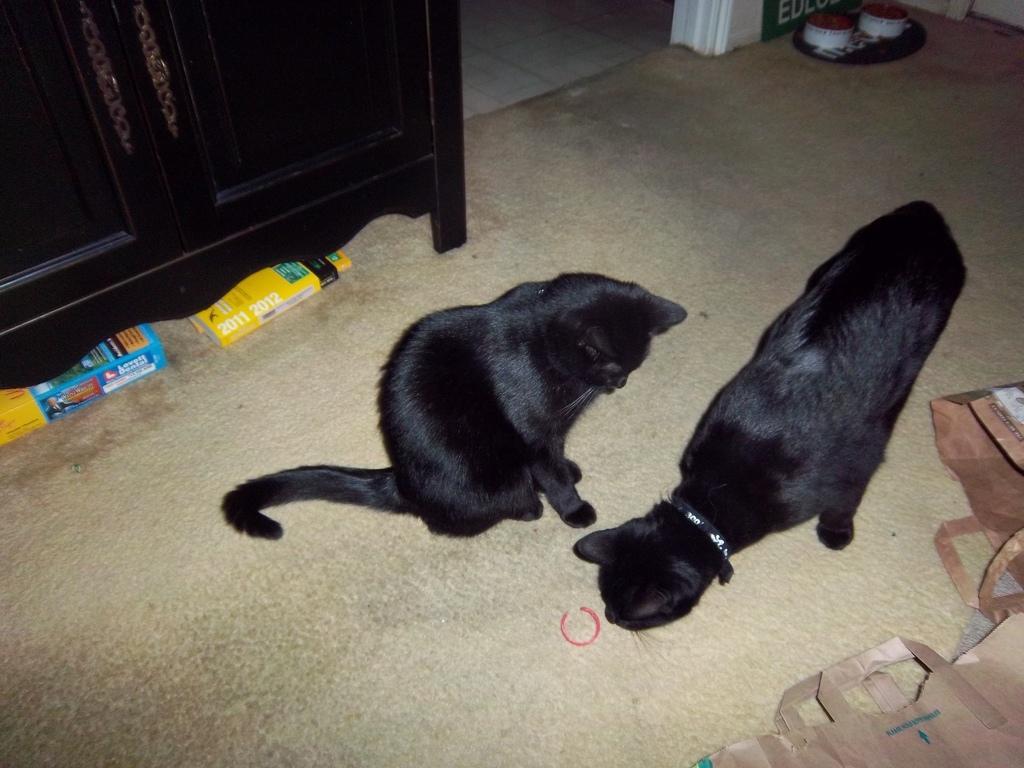How would you summarize this image in a sentence or two? In this image we can see two black color cats on the floor. We can also see two books, paper covers and also some objects. We can also see the wooden cupboard in this image. 